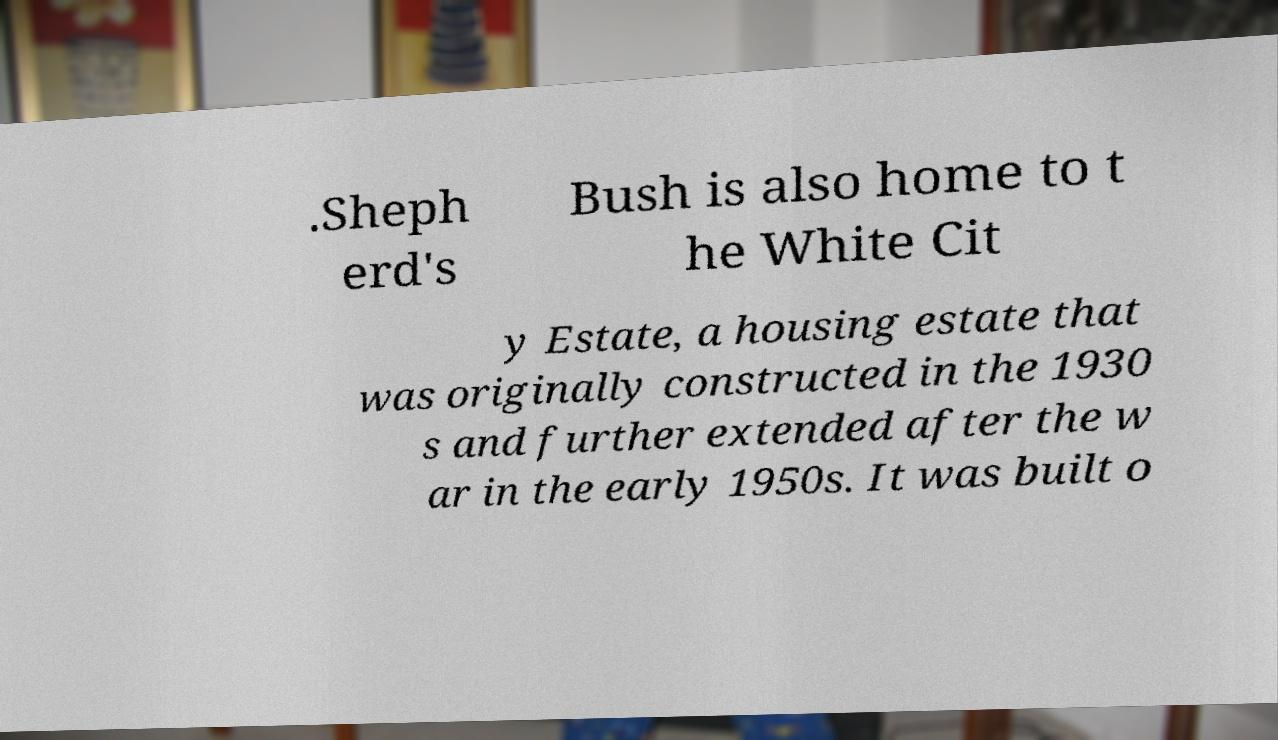Could you extract and type out the text from this image? .Sheph erd's Bush is also home to t he White Cit y Estate, a housing estate that was originally constructed in the 1930 s and further extended after the w ar in the early 1950s. It was built o 